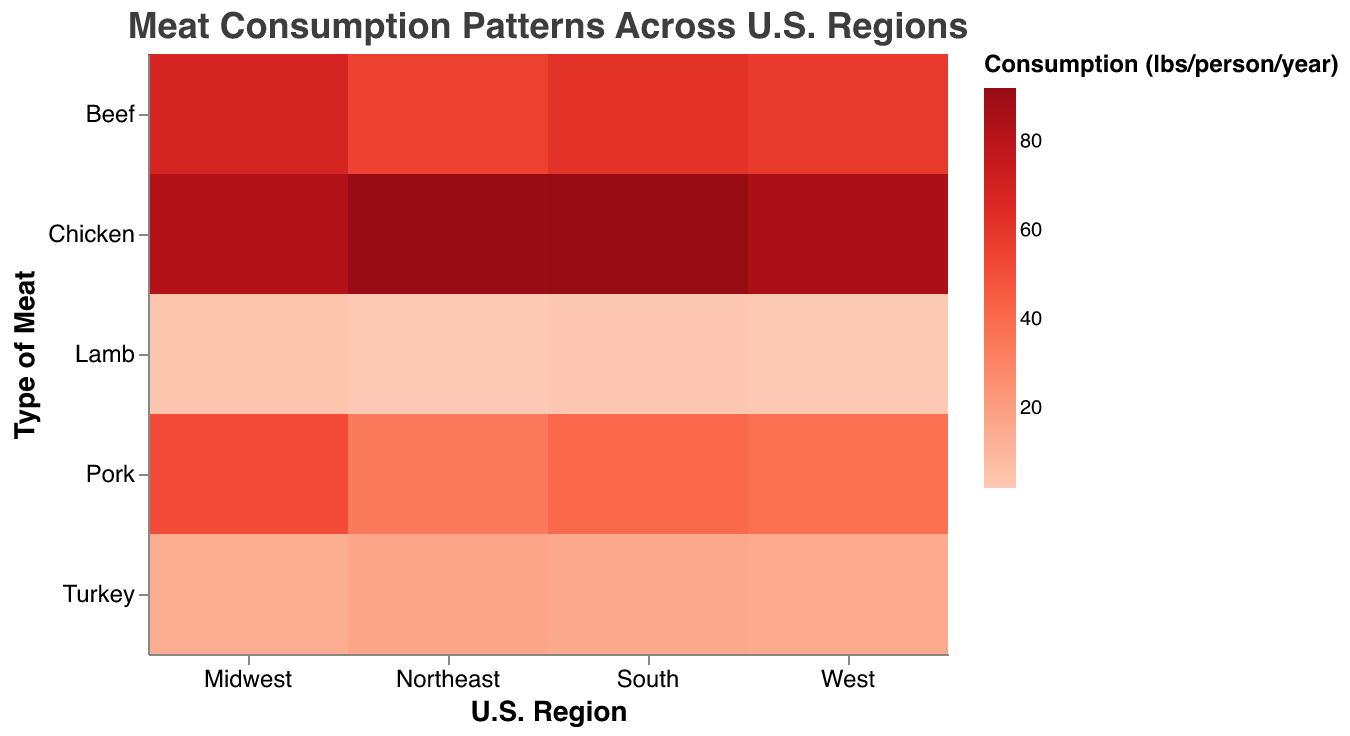Which region consumes the most beef on average per person per year? To find the region that consumes the most beef, we refer to the heatmap and look at the values for beef consumption across all regions. The Midwest has the highest value for beef consumption, which is 68 lbs/person/year.
Answer: Midwest Which type of meat is consumed the least in the Northeast region? To identify the least consumed meat type in the Northeast, we check the values corresponding to each meat type in the Northeast. Lamb has the lowest consumption at 2 lbs/person/year.
Answer: Lamb What's the total annual consumption of chicken per person in the South and Midwest combined? Sum the chicken consumption values for the South and Midwest: 92 lbs/person/year (South) + 83 lbs/person/year (Midwest) = 175 lbs/person/year.
Answer: 175 Which region has greater turkey consumption: the Northeast or the West? Compare the turkey consumption values between the Northeast (17 lbs/person/year) and the West (15 lbs/person/year). The Northeast has higher turkey consumption.
Answer: Northeast What is the difference in beef consumption between the region with the highest and the region with the lowest beef consumption? Identify the highest and lowest values for beef consumption: Midwest (68 lbs/person/year) and Northeast (55 lbs/person/year). Calculate the difference: 68 - 55 = 13 lbs/person/year.
Answer: 13 Which type of meat has the most consistent consumption across all regions? To find the most consistent meat consumption, observe the variability in the heatmap values across regions. Beef, pork, chicken, lamb, and turkey vary slightly, but chicken consumption (ranging from 83 to 92 lbs/person/year) seems to be the most consistent.
Answer: Chicken What is the average pork consumption per person per year across all regions? Sum the pork consumption values across all regions and divide by the number of regions: (34 + 51 + 41 + 38)/4 = 41 lbs/person/year.
Answer: 41 How does the consumption of lamb in the Midwest compare to other regions? Compare the lamb consumption value in the Midwest (4 lbs/person/year) to the values in other regions: Northeast (2 lbs/person/year), South (3 lbs/person/year), West (2 lbs/person/year). The Midwest has the highest lamb consumption.
Answer: Highest in Midwest 